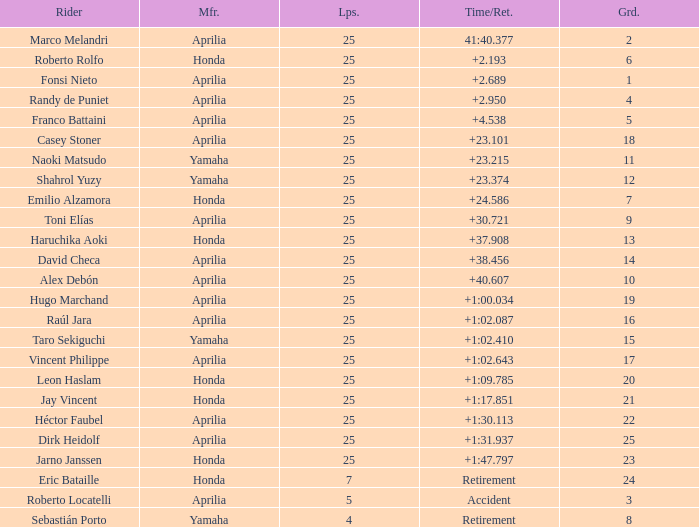Which Grid has Laps of 25, and a Manufacturer of honda, and a Time/Retired of +1:47.797? 23.0. 